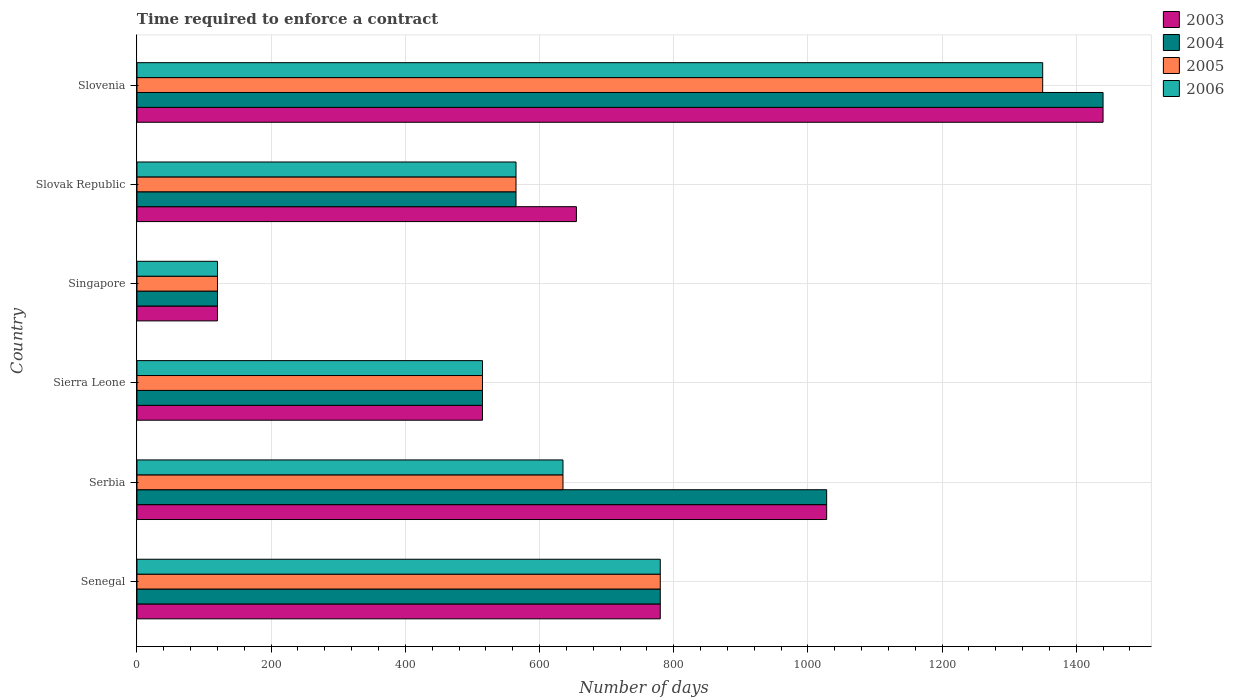How many different coloured bars are there?
Offer a very short reply. 4. How many groups of bars are there?
Ensure brevity in your answer.  6. What is the label of the 2nd group of bars from the top?
Your answer should be compact. Slovak Republic. What is the number of days required to enforce a contract in 2006 in Slovenia?
Ensure brevity in your answer.  1350. Across all countries, what is the maximum number of days required to enforce a contract in 2004?
Ensure brevity in your answer.  1440. Across all countries, what is the minimum number of days required to enforce a contract in 2005?
Keep it short and to the point. 120. In which country was the number of days required to enforce a contract in 2003 maximum?
Make the answer very short. Slovenia. In which country was the number of days required to enforce a contract in 2006 minimum?
Your answer should be compact. Singapore. What is the total number of days required to enforce a contract in 2006 in the graph?
Offer a very short reply. 3965. What is the difference between the number of days required to enforce a contract in 2004 in Senegal and that in Singapore?
Keep it short and to the point. 660. What is the difference between the number of days required to enforce a contract in 2004 in Senegal and the number of days required to enforce a contract in 2005 in Singapore?
Make the answer very short. 660. What is the average number of days required to enforce a contract in 2005 per country?
Provide a succinct answer. 660.83. What is the ratio of the number of days required to enforce a contract in 2003 in Sierra Leone to that in Slovenia?
Keep it short and to the point. 0.36. Is the number of days required to enforce a contract in 2003 in Sierra Leone less than that in Slovak Republic?
Offer a terse response. Yes. Is the difference between the number of days required to enforce a contract in 2006 in Sierra Leone and Slovak Republic greater than the difference between the number of days required to enforce a contract in 2005 in Sierra Leone and Slovak Republic?
Your answer should be very brief. No. What is the difference between the highest and the second highest number of days required to enforce a contract in 2006?
Offer a very short reply. 570. What is the difference between the highest and the lowest number of days required to enforce a contract in 2005?
Provide a succinct answer. 1230. In how many countries, is the number of days required to enforce a contract in 2005 greater than the average number of days required to enforce a contract in 2005 taken over all countries?
Offer a terse response. 2. Is the sum of the number of days required to enforce a contract in 2005 in Senegal and Serbia greater than the maximum number of days required to enforce a contract in 2003 across all countries?
Offer a very short reply. No. What does the 2nd bar from the bottom in Slovak Republic represents?
Ensure brevity in your answer.  2004. Is it the case that in every country, the sum of the number of days required to enforce a contract in 2004 and number of days required to enforce a contract in 2006 is greater than the number of days required to enforce a contract in 2005?
Make the answer very short. Yes. Are all the bars in the graph horizontal?
Provide a succinct answer. Yes. How many countries are there in the graph?
Provide a short and direct response. 6. Are the values on the major ticks of X-axis written in scientific E-notation?
Make the answer very short. No. Where does the legend appear in the graph?
Keep it short and to the point. Top right. How many legend labels are there?
Your answer should be compact. 4. How are the legend labels stacked?
Keep it short and to the point. Vertical. What is the title of the graph?
Provide a succinct answer. Time required to enforce a contract. What is the label or title of the X-axis?
Offer a very short reply. Number of days. What is the Number of days of 2003 in Senegal?
Offer a very short reply. 780. What is the Number of days of 2004 in Senegal?
Offer a terse response. 780. What is the Number of days in 2005 in Senegal?
Keep it short and to the point. 780. What is the Number of days in 2006 in Senegal?
Ensure brevity in your answer.  780. What is the Number of days of 2003 in Serbia?
Offer a very short reply. 1028. What is the Number of days of 2004 in Serbia?
Make the answer very short. 1028. What is the Number of days of 2005 in Serbia?
Keep it short and to the point. 635. What is the Number of days of 2006 in Serbia?
Your answer should be very brief. 635. What is the Number of days of 2003 in Sierra Leone?
Provide a succinct answer. 515. What is the Number of days in 2004 in Sierra Leone?
Give a very brief answer. 515. What is the Number of days of 2005 in Sierra Leone?
Offer a very short reply. 515. What is the Number of days of 2006 in Sierra Leone?
Ensure brevity in your answer.  515. What is the Number of days of 2003 in Singapore?
Your response must be concise. 120. What is the Number of days of 2004 in Singapore?
Offer a terse response. 120. What is the Number of days of 2005 in Singapore?
Ensure brevity in your answer.  120. What is the Number of days in 2006 in Singapore?
Your answer should be very brief. 120. What is the Number of days in 2003 in Slovak Republic?
Give a very brief answer. 655. What is the Number of days in 2004 in Slovak Republic?
Provide a short and direct response. 565. What is the Number of days of 2005 in Slovak Republic?
Give a very brief answer. 565. What is the Number of days in 2006 in Slovak Republic?
Ensure brevity in your answer.  565. What is the Number of days of 2003 in Slovenia?
Offer a terse response. 1440. What is the Number of days of 2004 in Slovenia?
Your answer should be compact. 1440. What is the Number of days in 2005 in Slovenia?
Keep it short and to the point. 1350. What is the Number of days of 2006 in Slovenia?
Ensure brevity in your answer.  1350. Across all countries, what is the maximum Number of days of 2003?
Keep it short and to the point. 1440. Across all countries, what is the maximum Number of days of 2004?
Give a very brief answer. 1440. Across all countries, what is the maximum Number of days in 2005?
Keep it short and to the point. 1350. Across all countries, what is the maximum Number of days of 2006?
Offer a very short reply. 1350. Across all countries, what is the minimum Number of days in 2003?
Your answer should be compact. 120. Across all countries, what is the minimum Number of days in 2004?
Your response must be concise. 120. Across all countries, what is the minimum Number of days in 2005?
Your answer should be very brief. 120. Across all countries, what is the minimum Number of days of 2006?
Provide a succinct answer. 120. What is the total Number of days of 2003 in the graph?
Your response must be concise. 4538. What is the total Number of days in 2004 in the graph?
Ensure brevity in your answer.  4448. What is the total Number of days of 2005 in the graph?
Your response must be concise. 3965. What is the total Number of days in 2006 in the graph?
Ensure brevity in your answer.  3965. What is the difference between the Number of days in 2003 in Senegal and that in Serbia?
Ensure brevity in your answer.  -248. What is the difference between the Number of days of 2004 in Senegal and that in Serbia?
Give a very brief answer. -248. What is the difference between the Number of days of 2005 in Senegal and that in Serbia?
Provide a succinct answer. 145. What is the difference between the Number of days in 2006 in Senegal and that in Serbia?
Your answer should be very brief. 145. What is the difference between the Number of days in 2003 in Senegal and that in Sierra Leone?
Your answer should be compact. 265. What is the difference between the Number of days of 2004 in Senegal and that in Sierra Leone?
Provide a succinct answer. 265. What is the difference between the Number of days of 2005 in Senegal and that in Sierra Leone?
Give a very brief answer. 265. What is the difference between the Number of days of 2006 in Senegal and that in Sierra Leone?
Offer a terse response. 265. What is the difference between the Number of days in 2003 in Senegal and that in Singapore?
Offer a terse response. 660. What is the difference between the Number of days of 2004 in Senegal and that in Singapore?
Your response must be concise. 660. What is the difference between the Number of days of 2005 in Senegal and that in Singapore?
Offer a very short reply. 660. What is the difference between the Number of days in 2006 in Senegal and that in Singapore?
Provide a short and direct response. 660. What is the difference between the Number of days of 2003 in Senegal and that in Slovak Republic?
Give a very brief answer. 125. What is the difference between the Number of days of 2004 in Senegal and that in Slovak Republic?
Your response must be concise. 215. What is the difference between the Number of days in 2005 in Senegal and that in Slovak Republic?
Your answer should be compact. 215. What is the difference between the Number of days of 2006 in Senegal and that in Slovak Republic?
Offer a terse response. 215. What is the difference between the Number of days of 2003 in Senegal and that in Slovenia?
Offer a very short reply. -660. What is the difference between the Number of days in 2004 in Senegal and that in Slovenia?
Provide a short and direct response. -660. What is the difference between the Number of days in 2005 in Senegal and that in Slovenia?
Keep it short and to the point. -570. What is the difference between the Number of days of 2006 in Senegal and that in Slovenia?
Offer a very short reply. -570. What is the difference between the Number of days of 2003 in Serbia and that in Sierra Leone?
Offer a very short reply. 513. What is the difference between the Number of days of 2004 in Serbia and that in Sierra Leone?
Offer a very short reply. 513. What is the difference between the Number of days of 2005 in Serbia and that in Sierra Leone?
Keep it short and to the point. 120. What is the difference between the Number of days of 2006 in Serbia and that in Sierra Leone?
Give a very brief answer. 120. What is the difference between the Number of days in 2003 in Serbia and that in Singapore?
Offer a terse response. 908. What is the difference between the Number of days of 2004 in Serbia and that in Singapore?
Offer a very short reply. 908. What is the difference between the Number of days of 2005 in Serbia and that in Singapore?
Provide a short and direct response. 515. What is the difference between the Number of days in 2006 in Serbia and that in Singapore?
Provide a short and direct response. 515. What is the difference between the Number of days in 2003 in Serbia and that in Slovak Republic?
Your response must be concise. 373. What is the difference between the Number of days of 2004 in Serbia and that in Slovak Republic?
Keep it short and to the point. 463. What is the difference between the Number of days in 2006 in Serbia and that in Slovak Republic?
Make the answer very short. 70. What is the difference between the Number of days of 2003 in Serbia and that in Slovenia?
Provide a short and direct response. -412. What is the difference between the Number of days of 2004 in Serbia and that in Slovenia?
Your answer should be very brief. -412. What is the difference between the Number of days in 2005 in Serbia and that in Slovenia?
Provide a succinct answer. -715. What is the difference between the Number of days of 2006 in Serbia and that in Slovenia?
Provide a short and direct response. -715. What is the difference between the Number of days of 2003 in Sierra Leone and that in Singapore?
Give a very brief answer. 395. What is the difference between the Number of days in 2004 in Sierra Leone and that in Singapore?
Give a very brief answer. 395. What is the difference between the Number of days of 2005 in Sierra Leone and that in Singapore?
Keep it short and to the point. 395. What is the difference between the Number of days in 2006 in Sierra Leone and that in Singapore?
Your answer should be very brief. 395. What is the difference between the Number of days of 2003 in Sierra Leone and that in Slovak Republic?
Offer a very short reply. -140. What is the difference between the Number of days in 2006 in Sierra Leone and that in Slovak Republic?
Offer a very short reply. -50. What is the difference between the Number of days of 2003 in Sierra Leone and that in Slovenia?
Provide a short and direct response. -925. What is the difference between the Number of days of 2004 in Sierra Leone and that in Slovenia?
Offer a terse response. -925. What is the difference between the Number of days of 2005 in Sierra Leone and that in Slovenia?
Your answer should be very brief. -835. What is the difference between the Number of days of 2006 in Sierra Leone and that in Slovenia?
Your response must be concise. -835. What is the difference between the Number of days in 2003 in Singapore and that in Slovak Republic?
Make the answer very short. -535. What is the difference between the Number of days in 2004 in Singapore and that in Slovak Republic?
Provide a short and direct response. -445. What is the difference between the Number of days in 2005 in Singapore and that in Slovak Republic?
Give a very brief answer. -445. What is the difference between the Number of days in 2006 in Singapore and that in Slovak Republic?
Your answer should be very brief. -445. What is the difference between the Number of days in 2003 in Singapore and that in Slovenia?
Provide a succinct answer. -1320. What is the difference between the Number of days of 2004 in Singapore and that in Slovenia?
Offer a terse response. -1320. What is the difference between the Number of days of 2005 in Singapore and that in Slovenia?
Your answer should be very brief. -1230. What is the difference between the Number of days of 2006 in Singapore and that in Slovenia?
Your answer should be very brief. -1230. What is the difference between the Number of days in 2003 in Slovak Republic and that in Slovenia?
Offer a terse response. -785. What is the difference between the Number of days in 2004 in Slovak Republic and that in Slovenia?
Give a very brief answer. -875. What is the difference between the Number of days of 2005 in Slovak Republic and that in Slovenia?
Ensure brevity in your answer.  -785. What is the difference between the Number of days of 2006 in Slovak Republic and that in Slovenia?
Your response must be concise. -785. What is the difference between the Number of days of 2003 in Senegal and the Number of days of 2004 in Serbia?
Give a very brief answer. -248. What is the difference between the Number of days of 2003 in Senegal and the Number of days of 2005 in Serbia?
Give a very brief answer. 145. What is the difference between the Number of days of 2003 in Senegal and the Number of days of 2006 in Serbia?
Keep it short and to the point. 145. What is the difference between the Number of days of 2004 in Senegal and the Number of days of 2005 in Serbia?
Provide a short and direct response. 145. What is the difference between the Number of days in 2004 in Senegal and the Number of days in 2006 in Serbia?
Offer a terse response. 145. What is the difference between the Number of days in 2005 in Senegal and the Number of days in 2006 in Serbia?
Provide a succinct answer. 145. What is the difference between the Number of days of 2003 in Senegal and the Number of days of 2004 in Sierra Leone?
Ensure brevity in your answer.  265. What is the difference between the Number of days of 2003 in Senegal and the Number of days of 2005 in Sierra Leone?
Keep it short and to the point. 265. What is the difference between the Number of days of 2003 in Senegal and the Number of days of 2006 in Sierra Leone?
Offer a terse response. 265. What is the difference between the Number of days in 2004 in Senegal and the Number of days in 2005 in Sierra Leone?
Offer a terse response. 265. What is the difference between the Number of days of 2004 in Senegal and the Number of days of 2006 in Sierra Leone?
Offer a terse response. 265. What is the difference between the Number of days of 2005 in Senegal and the Number of days of 2006 in Sierra Leone?
Your answer should be compact. 265. What is the difference between the Number of days of 2003 in Senegal and the Number of days of 2004 in Singapore?
Offer a terse response. 660. What is the difference between the Number of days of 2003 in Senegal and the Number of days of 2005 in Singapore?
Offer a very short reply. 660. What is the difference between the Number of days of 2003 in Senegal and the Number of days of 2006 in Singapore?
Make the answer very short. 660. What is the difference between the Number of days in 2004 in Senegal and the Number of days in 2005 in Singapore?
Offer a terse response. 660. What is the difference between the Number of days of 2004 in Senegal and the Number of days of 2006 in Singapore?
Give a very brief answer. 660. What is the difference between the Number of days in 2005 in Senegal and the Number of days in 2006 in Singapore?
Give a very brief answer. 660. What is the difference between the Number of days in 2003 in Senegal and the Number of days in 2004 in Slovak Republic?
Offer a very short reply. 215. What is the difference between the Number of days in 2003 in Senegal and the Number of days in 2005 in Slovak Republic?
Your answer should be very brief. 215. What is the difference between the Number of days in 2003 in Senegal and the Number of days in 2006 in Slovak Republic?
Ensure brevity in your answer.  215. What is the difference between the Number of days in 2004 in Senegal and the Number of days in 2005 in Slovak Republic?
Give a very brief answer. 215. What is the difference between the Number of days of 2004 in Senegal and the Number of days of 2006 in Slovak Republic?
Your answer should be compact. 215. What is the difference between the Number of days of 2005 in Senegal and the Number of days of 2006 in Slovak Republic?
Your answer should be very brief. 215. What is the difference between the Number of days in 2003 in Senegal and the Number of days in 2004 in Slovenia?
Ensure brevity in your answer.  -660. What is the difference between the Number of days of 2003 in Senegal and the Number of days of 2005 in Slovenia?
Ensure brevity in your answer.  -570. What is the difference between the Number of days of 2003 in Senegal and the Number of days of 2006 in Slovenia?
Keep it short and to the point. -570. What is the difference between the Number of days of 2004 in Senegal and the Number of days of 2005 in Slovenia?
Provide a short and direct response. -570. What is the difference between the Number of days of 2004 in Senegal and the Number of days of 2006 in Slovenia?
Provide a succinct answer. -570. What is the difference between the Number of days of 2005 in Senegal and the Number of days of 2006 in Slovenia?
Ensure brevity in your answer.  -570. What is the difference between the Number of days of 2003 in Serbia and the Number of days of 2004 in Sierra Leone?
Your answer should be compact. 513. What is the difference between the Number of days in 2003 in Serbia and the Number of days in 2005 in Sierra Leone?
Keep it short and to the point. 513. What is the difference between the Number of days in 2003 in Serbia and the Number of days in 2006 in Sierra Leone?
Keep it short and to the point. 513. What is the difference between the Number of days in 2004 in Serbia and the Number of days in 2005 in Sierra Leone?
Your answer should be compact. 513. What is the difference between the Number of days of 2004 in Serbia and the Number of days of 2006 in Sierra Leone?
Provide a succinct answer. 513. What is the difference between the Number of days of 2005 in Serbia and the Number of days of 2006 in Sierra Leone?
Offer a very short reply. 120. What is the difference between the Number of days of 2003 in Serbia and the Number of days of 2004 in Singapore?
Offer a terse response. 908. What is the difference between the Number of days of 2003 in Serbia and the Number of days of 2005 in Singapore?
Ensure brevity in your answer.  908. What is the difference between the Number of days in 2003 in Serbia and the Number of days in 2006 in Singapore?
Ensure brevity in your answer.  908. What is the difference between the Number of days of 2004 in Serbia and the Number of days of 2005 in Singapore?
Offer a terse response. 908. What is the difference between the Number of days in 2004 in Serbia and the Number of days in 2006 in Singapore?
Give a very brief answer. 908. What is the difference between the Number of days in 2005 in Serbia and the Number of days in 2006 in Singapore?
Provide a succinct answer. 515. What is the difference between the Number of days in 2003 in Serbia and the Number of days in 2004 in Slovak Republic?
Offer a terse response. 463. What is the difference between the Number of days in 2003 in Serbia and the Number of days in 2005 in Slovak Republic?
Your answer should be compact. 463. What is the difference between the Number of days of 2003 in Serbia and the Number of days of 2006 in Slovak Republic?
Provide a succinct answer. 463. What is the difference between the Number of days of 2004 in Serbia and the Number of days of 2005 in Slovak Republic?
Offer a terse response. 463. What is the difference between the Number of days of 2004 in Serbia and the Number of days of 2006 in Slovak Republic?
Provide a succinct answer. 463. What is the difference between the Number of days in 2003 in Serbia and the Number of days in 2004 in Slovenia?
Your answer should be compact. -412. What is the difference between the Number of days in 2003 in Serbia and the Number of days in 2005 in Slovenia?
Your answer should be very brief. -322. What is the difference between the Number of days of 2003 in Serbia and the Number of days of 2006 in Slovenia?
Ensure brevity in your answer.  -322. What is the difference between the Number of days of 2004 in Serbia and the Number of days of 2005 in Slovenia?
Offer a very short reply. -322. What is the difference between the Number of days of 2004 in Serbia and the Number of days of 2006 in Slovenia?
Provide a short and direct response. -322. What is the difference between the Number of days in 2005 in Serbia and the Number of days in 2006 in Slovenia?
Your response must be concise. -715. What is the difference between the Number of days in 2003 in Sierra Leone and the Number of days in 2004 in Singapore?
Ensure brevity in your answer.  395. What is the difference between the Number of days of 2003 in Sierra Leone and the Number of days of 2005 in Singapore?
Your response must be concise. 395. What is the difference between the Number of days in 2003 in Sierra Leone and the Number of days in 2006 in Singapore?
Offer a terse response. 395. What is the difference between the Number of days in 2004 in Sierra Leone and the Number of days in 2005 in Singapore?
Give a very brief answer. 395. What is the difference between the Number of days in 2004 in Sierra Leone and the Number of days in 2006 in Singapore?
Offer a very short reply. 395. What is the difference between the Number of days of 2005 in Sierra Leone and the Number of days of 2006 in Singapore?
Offer a very short reply. 395. What is the difference between the Number of days of 2004 in Sierra Leone and the Number of days of 2005 in Slovak Republic?
Your answer should be very brief. -50. What is the difference between the Number of days of 2004 in Sierra Leone and the Number of days of 2006 in Slovak Republic?
Keep it short and to the point. -50. What is the difference between the Number of days of 2003 in Sierra Leone and the Number of days of 2004 in Slovenia?
Make the answer very short. -925. What is the difference between the Number of days in 2003 in Sierra Leone and the Number of days in 2005 in Slovenia?
Your answer should be compact. -835. What is the difference between the Number of days of 2003 in Sierra Leone and the Number of days of 2006 in Slovenia?
Your answer should be very brief. -835. What is the difference between the Number of days of 2004 in Sierra Leone and the Number of days of 2005 in Slovenia?
Give a very brief answer. -835. What is the difference between the Number of days of 2004 in Sierra Leone and the Number of days of 2006 in Slovenia?
Your answer should be very brief. -835. What is the difference between the Number of days of 2005 in Sierra Leone and the Number of days of 2006 in Slovenia?
Make the answer very short. -835. What is the difference between the Number of days of 2003 in Singapore and the Number of days of 2004 in Slovak Republic?
Make the answer very short. -445. What is the difference between the Number of days of 2003 in Singapore and the Number of days of 2005 in Slovak Republic?
Provide a succinct answer. -445. What is the difference between the Number of days of 2003 in Singapore and the Number of days of 2006 in Slovak Republic?
Provide a short and direct response. -445. What is the difference between the Number of days of 2004 in Singapore and the Number of days of 2005 in Slovak Republic?
Ensure brevity in your answer.  -445. What is the difference between the Number of days in 2004 in Singapore and the Number of days in 2006 in Slovak Republic?
Your answer should be very brief. -445. What is the difference between the Number of days of 2005 in Singapore and the Number of days of 2006 in Slovak Republic?
Your response must be concise. -445. What is the difference between the Number of days of 2003 in Singapore and the Number of days of 2004 in Slovenia?
Give a very brief answer. -1320. What is the difference between the Number of days in 2003 in Singapore and the Number of days in 2005 in Slovenia?
Your answer should be very brief. -1230. What is the difference between the Number of days in 2003 in Singapore and the Number of days in 2006 in Slovenia?
Your answer should be compact. -1230. What is the difference between the Number of days of 2004 in Singapore and the Number of days of 2005 in Slovenia?
Ensure brevity in your answer.  -1230. What is the difference between the Number of days in 2004 in Singapore and the Number of days in 2006 in Slovenia?
Provide a short and direct response. -1230. What is the difference between the Number of days of 2005 in Singapore and the Number of days of 2006 in Slovenia?
Keep it short and to the point. -1230. What is the difference between the Number of days in 2003 in Slovak Republic and the Number of days in 2004 in Slovenia?
Provide a short and direct response. -785. What is the difference between the Number of days in 2003 in Slovak Republic and the Number of days in 2005 in Slovenia?
Make the answer very short. -695. What is the difference between the Number of days of 2003 in Slovak Republic and the Number of days of 2006 in Slovenia?
Offer a very short reply. -695. What is the difference between the Number of days of 2004 in Slovak Republic and the Number of days of 2005 in Slovenia?
Ensure brevity in your answer.  -785. What is the difference between the Number of days of 2004 in Slovak Republic and the Number of days of 2006 in Slovenia?
Ensure brevity in your answer.  -785. What is the difference between the Number of days of 2005 in Slovak Republic and the Number of days of 2006 in Slovenia?
Keep it short and to the point. -785. What is the average Number of days of 2003 per country?
Provide a succinct answer. 756.33. What is the average Number of days in 2004 per country?
Offer a terse response. 741.33. What is the average Number of days in 2005 per country?
Keep it short and to the point. 660.83. What is the average Number of days of 2006 per country?
Your answer should be compact. 660.83. What is the difference between the Number of days of 2003 and Number of days of 2005 in Senegal?
Your answer should be compact. 0. What is the difference between the Number of days in 2003 and Number of days in 2006 in Senegal?
Keep it short and to the point. 0. What is the difference between the Number of days of 2004 and Number of days of 2005 in Senegal?
Your answer should be compact. 0. What is the difference between the Number of days of 2004 and Number of days of 2006 in Senegal?
Make the answer very short. 0. What is the difference between the Number of days in 2003 and Number of days in 2005 in Serbia?
Keep it short and to the point. 393. What is the difference between the Number of days of 2003 and Number of days of 2006 in Serbia?
Your answer should be very brief. 393. What is the difference between the Number of days in 2004 and Number of days in 2005 in Serbia?
Provide a short and direct response. 393. What is the difference between the Number of days in 2004 and Number of days in 2006 in Serbia?
Your answer should be very brief. 393. What is the difference between the Number of days of 2003 and Number of days of 2005 in Sierra Leone?
Your response must be concise. 0. What is the difference between the Number of days in 2004 and Number of days in 2005 in Sierra Leone?
Provide a succinct answer. 0. What is the difference between the Number of days in 2004 and Number of days in 2006 in Sierra Leone?
Offer a terse response. 0. What is the difference between the Number of days in 2003 and Number of days in 2004 in Singapore?
Your answer should be compact. 0. What is the difference between the Number of days in 2003 and Number of days in 2005 in Singapore?
Your answer should be very brief. 0. What is the difference between the Number of days of 2003 and Number of days of 2006 in Singapore?
Give a very brief answer. 0. What is the difference between the Number of days of 2004 and Number of days of 2005 in Singapore?
Make the answer very short. 0. What is the difference between the Number of days of 2004 and Number of days of 2006 in Singapore?
Your answer should be very brief. 0. What is the difference between the Number of days in 2003 and Number of days in 2004 in Slovak Republic?
Provide a succinct answer. 90. What is the difference between the Number of days of 2003 and Number of days of 2005 in Slovak Republic?
Your response must be concise. 90. What is the difference between the Number of days in 2003 and Number of days in 2006 in Slovak Republic?
Your answer should be very brief. 90. What is the difference between the Number of days in 2004 and Number of days in 2005 in Slovak Republic?
Offer a very short reply. 0. What is the difference between the Number of days of 2003 and Number of days of 2004 in Slovenia?
Your answer should be very brief. 0. What is the difference between the Number of days in 2004 and Number of days in 2006 in Slovenia?
Your answer should be compact. 90. What is the ratio of the Number of days in 2003 in Senegal to that in Serbia?
Provide a short and direct response. 0.76. What is the ratio of the Number of days in 2004 in Senegal to that in Serbia?
Your response must be concise. 0.76. What is the ratio of the Number of days of 2005 in Senegal to that in Serbia?
Ensure brevity in your answer.  1.23. What is the ratio of the Number of days of 2006 in Senegal to that in Serbia?
Your response must be concise. 1.23. What is the ratio of the Number of days in 2003 in Senegal to that in Sierra Leone?
Make the answer very short. 1.51. What is the ratio of the Number of days in 2004 in Senegal to that in Sierra Leone?
Offer a very short reply. 1.51. What is the ratio of the Number of days in 2005 in Senegal to that in Sierra Leone?
Offer a terse response. 1.51. What is the ratio of the Number of days of 2006 in Senegal to that in Sierra Leone?
Give a very brief answer. 1.51. What is the ratio of the Number of days in 2003 in Senegal to that in Singapore?
Keep it short and to the point. 6.5. What is the ratio of the Number of days in 2005 in Senegal to that in Singapore?
Offer a terse response. 6.5. What is the ratio of the Number of days of 2003 in Senegal to that in Slovak Republic?
Ensure brevity in your answer.  1.19. What is the ratio of the Number of days in 2004 in Senegal to that in Slovak Republic?
Give a very brief answer. 1.38. What is the ratio of the Number of days in 2005 in Senegal to that in Slovak Republic?
Offer a terse response. 1.38. What is the ratio of the Number of days of 2006 in Senegal to that in Slovak Republic?
Keep it short and to the point. 1.38. What is the ratio of the Number of days in 2003 in Senegal to that in Slovenia?
Provide a short and direct response. 0.54. What is the ratio of the Number of days in 2004 in Senegal to that in Slovenia?
Provide a succinct answer. 0.54. What is the ratio of the Number of days of 2005 in Senegal to that in Slovenia?
Your answer should be compact. 0.58. What is the ratio of the Number of days of 2006 in Senegal to that in Slovenia?
Ensure brevity in your answer.  0.58. What is the ratio of the Number of days of 2003 in Serbia to that in Sierra Leone?
Ensure brevity in your answer.  2. What is the ratio of the Number of days in 2004 in Serbia to that in Sierra Leone?
Provide a succinct answer. 2. What is the ratio of the Number of days of 2005 in Serbia to that in Sierra Leone?
Ensure brevity in your answer.  1.23. What is the ratio of the Number of days in 2006 in Serbia to that in Sierra Leone?
Provide a short and direct response. 1.23. What is the ratio of the Number of days of 2003 in Serbia to that in Singapore?
Give a very brief answer. 8.57. What is the ratio of the Number of days of 2004 in Serbia to that in Singapore?
Offer a very short reply. 8.57. What is the ratio of the Number of days of 2005 in Serbia to that in Singapore?
Your response must be concise. 5.29. What is the ratio of the Number of days in 2006 in Serbia to that in Singapore?
Your answer should be compact. 5.29. What is the ratio of the Number of days of 2003 in Serbia to that in Slovak Republic?
Keep it short and to the point. 1.57. What is the ratio of the Number of days of 2004 in Serbia to that in Slovak Republic?
Your response must be concise. 1.82. What is the ratio of the Number of days in 2005 in Serbia to that in Slovak Republic?
Your answer should be very brief. 1.12. What is the ratio of the Number of days in 2006 in Serbia to that in Slovak Republic?
Provide a short and direct response. 1.12. What is the ratio of the Number of days of 2003 in Serbia to that in Slovenia?
Your response must be concise. 0.71. What is the ratio of the Number of days in 2004 in Serbia to that in Slovenia?
Provide a succinct answer. 0.71. What is the ratio of the Number of days of 2005 in Serbia to that in Slovenia?
Offer a very short reply. 0.47. What is the ratio of the Number of days of 2006 in Serbia to that in Slovenia?
Offer a terse response. 0.47. What is the ratio of the Number of days of 2003 in Sierra Leone to that in Singapore?
Make the answer very short. 4.29. What is the ratio of the Number of days in 2004 in Sierra Leone to that in Singapore?
Keep it short and to the point. 4.29. What is the ratio of the Number of days of 2005 in Sierra Leone to that in Singapore?
Give a very brief answer. 4.29. What is the ratio of the Number of days of 2006 in Sierra Leone to that in Singapore?
Make the answer very short. 4.29. What is the ratio of the Number of days in 2003 in Sierra Leone to that in Slovak Republic?
Offer a very short reply. 0.79. What is the ratio of the Number of days of 2004 in Sierra Leone to that in Slovak Republic?
Give a very brief answer. 0.91. What is the ratio of the Number of days of 2005 in Sierra Leone to that in Slovak Republic?
Offer a terse response. 0.91. What is the ratio of the Number of days in 2006 in Sierra Leone to that in Slovak Republic?
Offer a very short reply. 0.91. What is the ratio of the Number of days of 2003 in Sierra Leone to that in Slovenia?
Ensure brevity in your answer.  0.36. What is the ratio of the Number of days of 2004 in Sierra Leone to that in Slovenia?
Offer a very short reply. 0.36. What is the ratio of the Number of days in 2005 in Sierra Leone to that in Slovenia?
Offer a terse response. 0.38. What is the ratio of the Number of days of 2006 in Sierra Leone to that in Slovenia?
Make the answer very short. 0.38. What is the ratio of the Number of days in 2003 in Singapore to that in Slovak Republic?
Give a very brief answer. 0.18. What is the ratio of the Number of days in 2004 in Singapore to that in Slovak Republic?
Ensure brevity in your answer.  0.21. What is the ratio of the Number of days in 2005 in Singapore to that in Slovak Republic?
Offer a terse response. 0.21. What is the ratio of the Number of days in 2006 in Singapore to that in Slovak Republic?
Keep it short and to the point. 0.21. What is the ratio of the Number of days of 2003 in Singapore to that in Slovenia?
Your answer should be compact. 0.08. What is the ratio of the Number of days in 2004 in Singapore to that in Slovenia?
Your response must be concise. 0.08. What is the ratio of the Number of days in 2005 in Singapore to that in Slovenia?
Your answer should be very brief. 0.09. What is the ratio of the Number of days in 2006 in Singapore to that in Slovenia?
Keep it short and to the point. 0.09. What is the ratio of the Number of days in 2003 in Slovak Republic to that in Slovenia?
Give a very brief answer. 0.45. What is the ratio of the Number of days in 2004 in Slovak Republic to that in Slovenia?
Your response must be concise. 0.39. What is the ratio of the Number of days in 2005 in Slovak Republic to that in Slovenia?
Offer a terse response. 0.42. What is the ratio of the Number of days of 2006 in Slovak Republic to that in Slovenia?
Keep it short and to the point. 0.42. What is the difference between the highest and the second highest Number of days in 2003?
Make the answer very short. 412. What is the difference between the highest and the second highest Number of days of 2004?
Your response must be concise. 412. What is the difference between the highest and the second highest Number of days in 2005?
Ensure brevity in your answer.  570. What is the difference between the highest and the second highest Number of days of 2006?
Give a very brief answer. 570. What is the difference between the highest and the lowest Number of days in 2003?
Your answer should be compact. 1320. What is the difference between the highest and the lowest Number of days of 2004?
Give a very brief answer. 1320. What is the difference between the highest and the lowest Number of days in 2005?
Keep it short and to the point. 1230. What is the difference between the highest and the lowest Number of days in 2006?
Ensure brevity in your answer.  1230. 